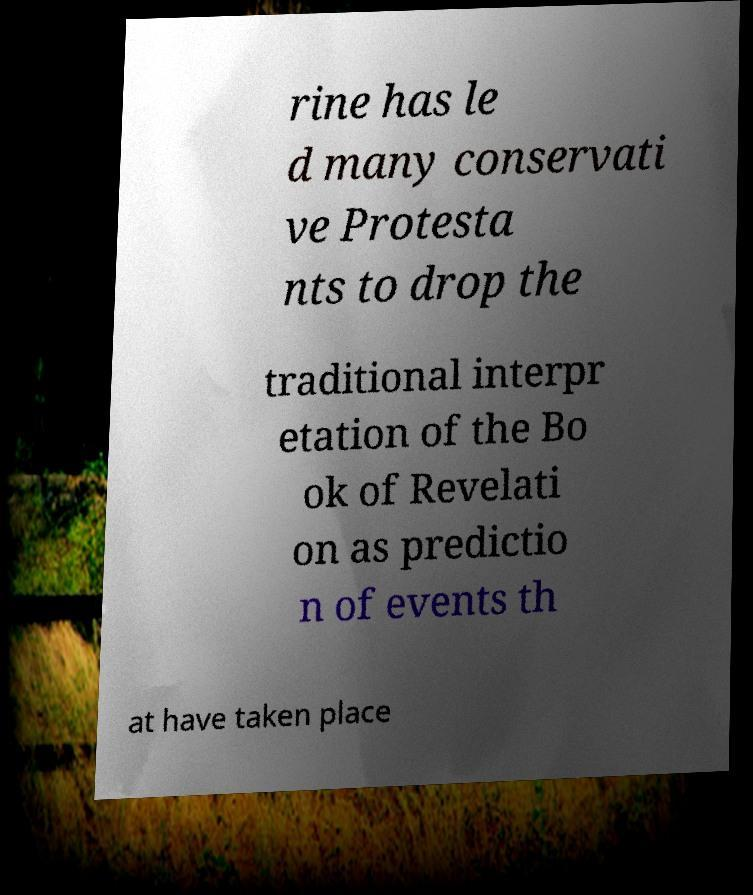Can you read and provide the text displayed in the image?This photo seems to have some interesting text. Can you extract and type it out for me? rine has le d many conservati ve Protesta nts to drop the traditional interpr etation of the Bo ok of Revelati on as predictio n of events th at have taken place 